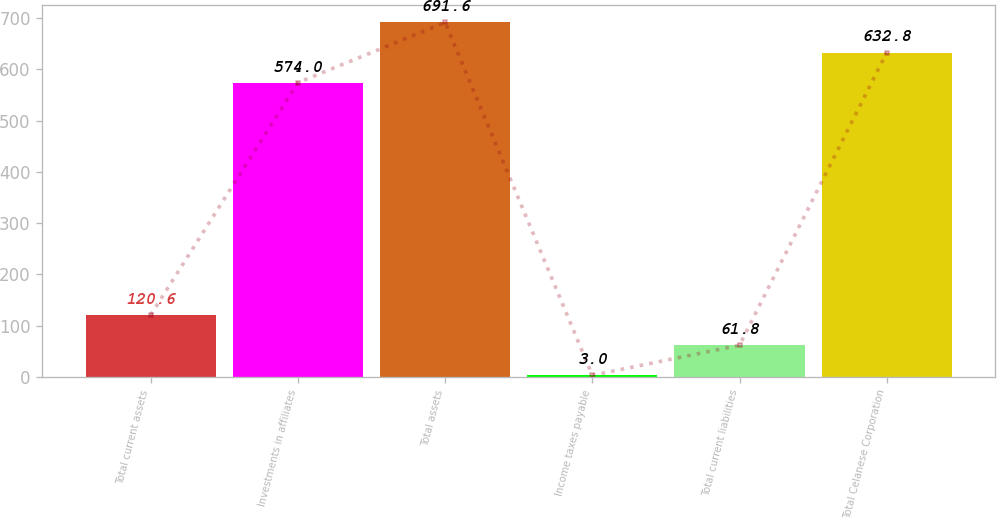Convert chart to OTSL. <chart><loc_0><loc_0><loc_500><loc_500><bar_chart><fcel>Total current assets<fcel>Investments in affiliates<fcel>Total assets<fcel>Income taxes payable<fcel>Total current liabilities<fcel>Total Celanese Corporation<nl><fcel>120.6<fcel>574<fcel>691.6<fcel>3<fcel>61.8<fcel>632.8<nl></chart> 